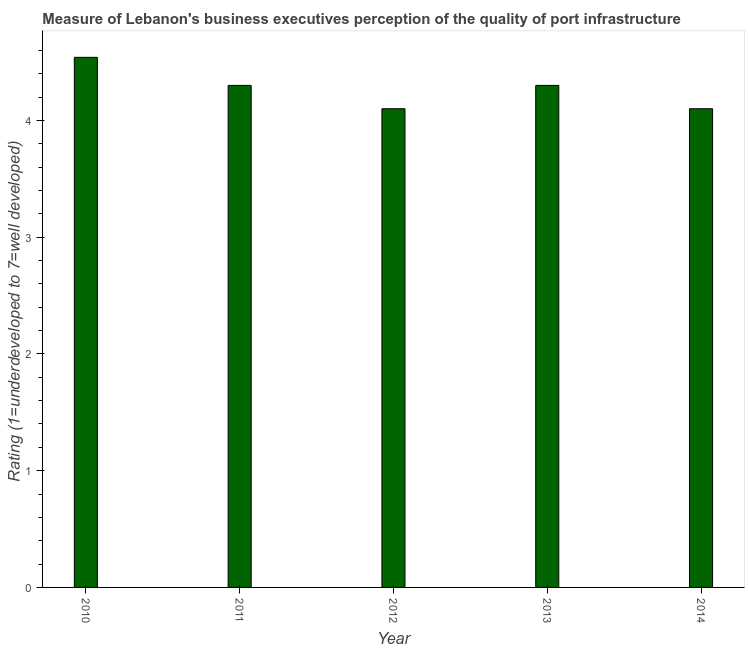Does the graph contain any zero values?
Your answer should be very brief. No. Does the graph contain grids?
Provide a succinct answer. No. What is the title of the graph?
Give a very brief answer. Measure of Lebanon's business executives perception of the quality of port infrastructure. What is the label or title of the X-axis?
Provide a short and direct response. Year. What is the label or title of the Y-axis?
Give a very brief answer. Rating (1=underdeveloped to 7=well developed) . What is the rating measuring quality of port infrastructure in 2011?
Keep it short and to the point. 4.3. Across all years, what is the maximum rating measuring quality of port infrastructure?
Keep it short and to the point. 4.54. Across all years, what is the minimum rating measuring quality of port infrastructure?
Provide a short and direct response. 4.1. In which year was the rating measuring quality of port infrastructure maximum?
Provide a short and direct response. 2010. In which year was the rating measuring quality of port infrastructure minimum?
Your answer should be compact. 2012. What is the sum of the rating measuring quality of port infrastructure?
Your response must be concise. 21.34. What is the difference between the rating measuring quality of port infrastructure in 2010 and 2011?
Keep it short and to the point. 0.24. What is the average rating measuring quality of port infrastructure per year?
Make the answer very short. 4.27. What is the median rating measuring quality of port infrastructure?
Your answer should be compact. 4.3. What is the ratio of the rating measuring quality of port infrastructure in 2010 to that in 2014?
Ensure brevity in your answer.  1.11. What is the difference between the highest and the second highest rating measuring quality of port infrastructure?
Keep it short and to the point. 0.24. Is the sum of the rating measuring quality of port infrastructure in 2011 and 2014 greater than the maximum rating measuring quality of port infrastructure across all years?
Provide a short and direct response. Yes. What is the difference between the highest and the lowest rating measuring quality of port infrastructure?
Provide a short and direct response. 0.44. How many bars are there?
Your response must be concise. 5. Are all the bars in the graph horizontal?
Provide a succinct answer. No. How many years are there in the graph?
Provide a short and direct response. 5. Are the values on the major ticks of Y-axis written in scientific E-notation?
Give a very brief answer. No. What is the Rating (1=underdeveloped to 7=well developed)  of 2010?
Give a very brief answer. 4.54. What is the Rating (1=underdeveloped to 7=well developed)  in 2012?
Make the answer very short. 4.1. What is the difference between the Rating (1=underdeveloped to 7=well developed)  in 2010 and 2011?
Your answer should be very brief. 0.24. What is the difference between the Rating (1=underdeveloped to 7=well developed)  in 2010 and 2012?
Your answer should be compact. 0.44. What is the difference between the Rating (1=underdeveloped to 7=well developed)  in 2010 and 2013?
Provide a succinct answer. 0.24. What is the difference between the Rating (1=underdeveloped to 7=well developed)  in 2010 and 2014?
Your answer should be very brief. 0.44. What is the difference between the Rating (1=underdeveloped to 7=well developed)  in 2011 and 2012?
Keep it short and to the point. 0.2. What is the difference between the Rating (1=underdeveloped to 7=well developed)  in 2011 and 2013?
Give a very brief answer. 0. What is the difference between the Rating (1=underdeveloped to 7=well developed)  in 2011 and 2014?
Keep it short and to the point. 0.2. What is the difference between the Rating (1=underdeveloped to 7=well developed)  in 2012 and 2013?
Your answer should be very brief. -0.2. What is the difference between the Rating (1=underdeveloped to 7=well developed)  in 2012 and 2014?
Your response must be concise. 0. What is the difference between the Rating (1=underdeveloped to 7=well developed)  in 2013 and 2014?
Ensure brevity in your answer.  0.2. What is the ratio of the Rating (1=underdeveloped to 7=well developed)  in 2010 to that in 2011?
Ensure brevity in your answer.  1.06. What is the ratio of the Rating (1=underdeveloped to 7=well developed)  in 2010 to that in 2012?
Offer a terse response. 1.11. What is the ratio of the Rating (1=underdeveloped to 7=well developed)  in 2010 to that in 2013?
Your answer should be very brief. 1.06. What is the ratio of the Rating (1=underdeveloped to 7=well developed)  in 2010 to that in 2014?
Offer a very short reply. 1.11. What is the ratio of the Rating (1=underdeveloped to 7=well developed)  in 2011 to that in 2012?
Your response must be concise. 1.05. What is the ratio of the Rating (1=underdeveloped to 7=well developed)  in 2011 to that in 2014?
Give a very brief answer. 1.05. What is the ratio of the Rating (1=underdeveloped to 7=well developed)  in 2012 to that in 2013?
Make the answer very short. 0.95. What is the ratio of the Rating (1=underdeveloped to 7=well developed)  in 2012 to that in 2014?
Your answer should be compact. 1. What is the ratio of the Rating (1=underdeveloped to 7=well developed)  in 2013 to that in 2014?
Offer a very short reply. 1.05. 